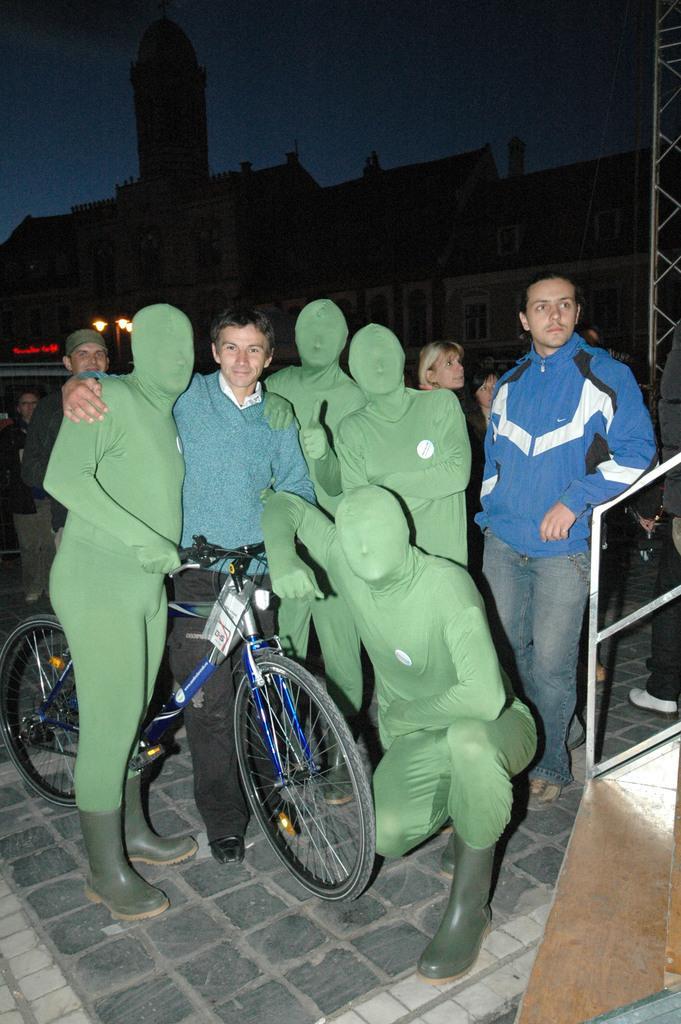Describe this image in one or two sentences. In this image there is a man in the middle who is holding the cycle. There are few people around him who are wearing the green colour mask. On the right side there is another man standing on the floor. In the background there are buildings. At the top there is the sky. There are some lights in the background. 